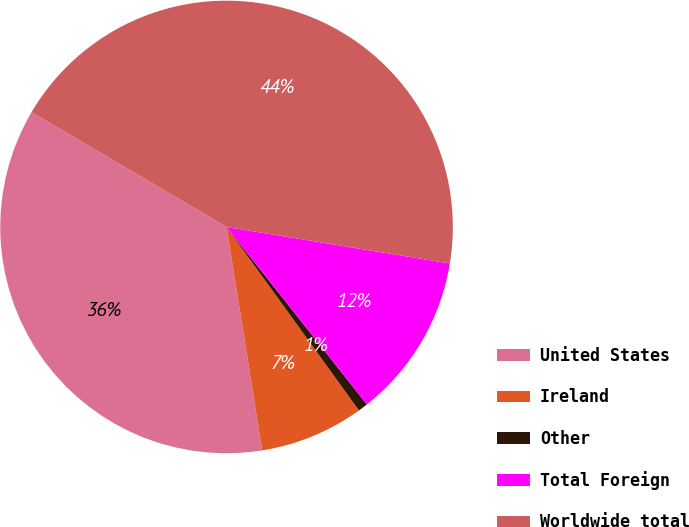Convert chart to OTSL. <chart><loc_0><loc_0><loc_500><loc_500><pie_chart><fcel>United States<fcel>Ireland<fcel>Other<fcel>Total Foreign<fcel>Worldwide total<nl><fcel>35.98%<fcel>7.43%<fcel>0.7%<fcel>11.77%<fcel>44.11%<nl></chart> 